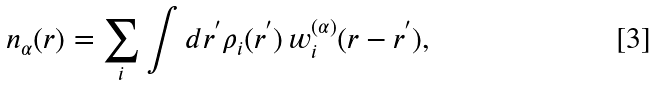Convert formula to latex. <formula><loc_0><loc_0><loc_500><loc_500>n _ { \alpha } ( { r } ) = \sum _ { i } \int d { r } ^ { ^ { \prime } } \rho _ { i } ( { r } ^ { ^ { \prime } } ) \, w ^ { ( \alpha ) } _ { i } ( { r } - { r } ^ { ^ { \prime } } ) ,</formula> 